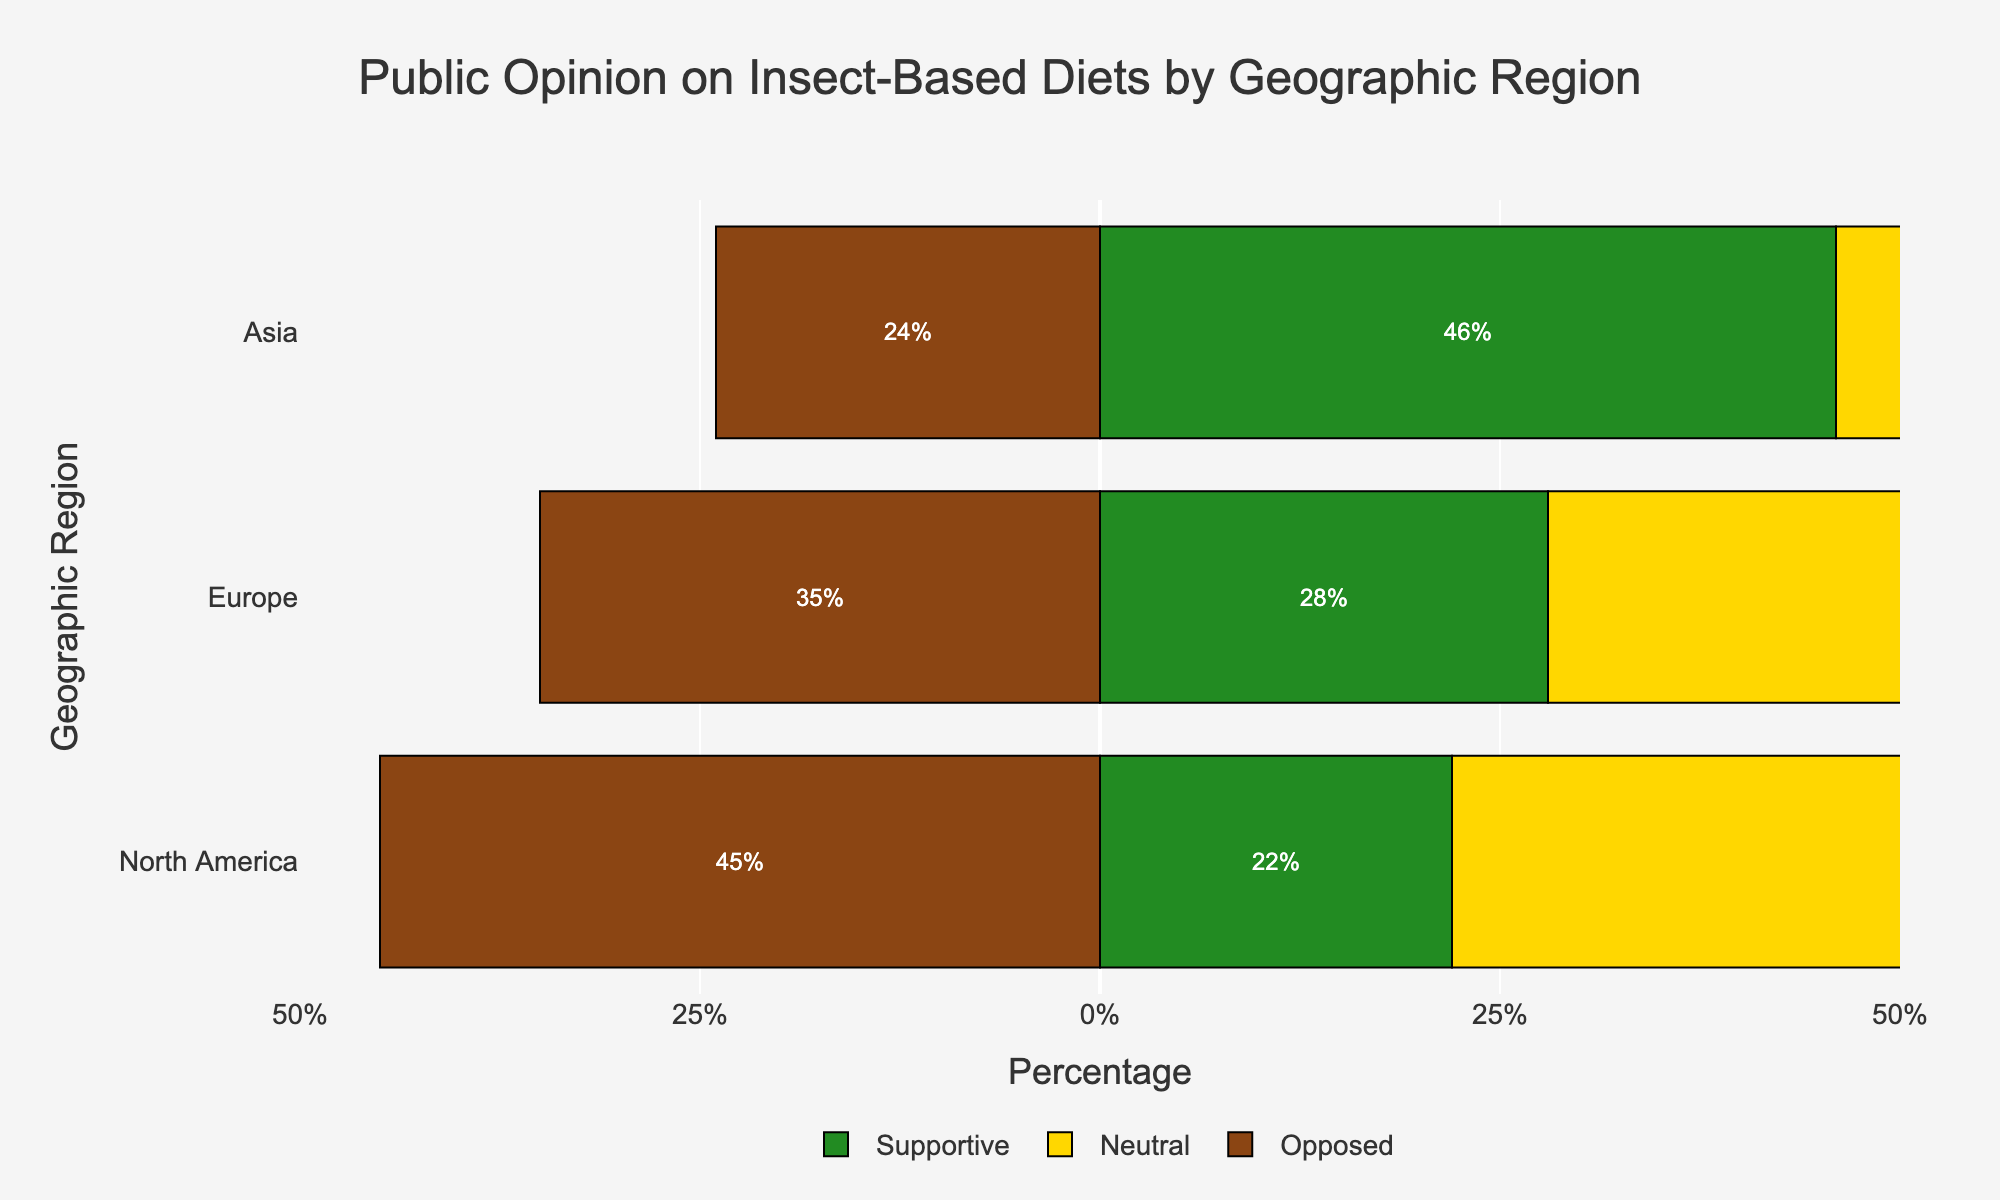What geographic region has the highest percentage of support for insect-based diets? By observing the chart, Asia has the longest green bar on the right (supportive) among all regions. This indicates the highest percentage of support for insect-based diets.
Answer: Asia Which geographic region has the highest percentage of opposition to insect-based diets? The longest brown bar on the left (opposed) represents North America. This means North America has the highest percentage of opposition.
Answer: North America Compare the percentage of neutrality towards insect-based diets between Europe and Asia. Europe has a longer yellow bar (neutral) than Asia. Specifically, Europe has 37% neutrality while Asia has 30% neutrality towards insect-based diets.
Answer: Europe What is the total percentage of people in North America who are either supportive or opposed to insect-based diets? The supportive percentage is 22% and the opposed percentage is 45%. Adding these together gives 22% + 45% = 67%.
Answer: 67% How does the percentage of neutrality in North America compare to the percentage of neutrality in Europe? North America's neutral percentage is 33% while Europe's is 37%. Europe has a 4% higher neutrality towards insect-based diets compared to North America.
Answer: 4% higher Which geographic region shows the most balanced opinion on insect-based diets, considering all three opinions' bar lengths? By comparing the lengths of the green, yellow, and brown bars for each region, Europe shows the most balanced opinion because the lengths of its supportive, neutral, and opposed bars are most similar.
Answer: Europe What is the difference between the percentages of supportive and opposed opinions in Asia? The supportive percentage in Asia is 46%, and the opposed percentage is 24%. The difference is 46% - 24% = 22%.
Answer: 22% Which geographic region has the highest percentage of neutrality towards insect-based diets? Among the yellow bars indicating neutrality, the longest one belongs to Europe which has 37% neutrality.
Answer: Europe How much higher is the percentage of opposition in North America compared to the supportive percentage in the same region? In North America, the opposed percentage is 45% and the supportive percentage is 22%. The difference is 45% - 22% = 23%.
Answer: 23% What is the combined percentage of people in Asia who are either supportive or neutral towards insect-based diets? The supportive percentage in Asia is 46%, and the neutral percentage is 30%. Adding these together gives 46% + 30% = 76%.
Answer: 76% 